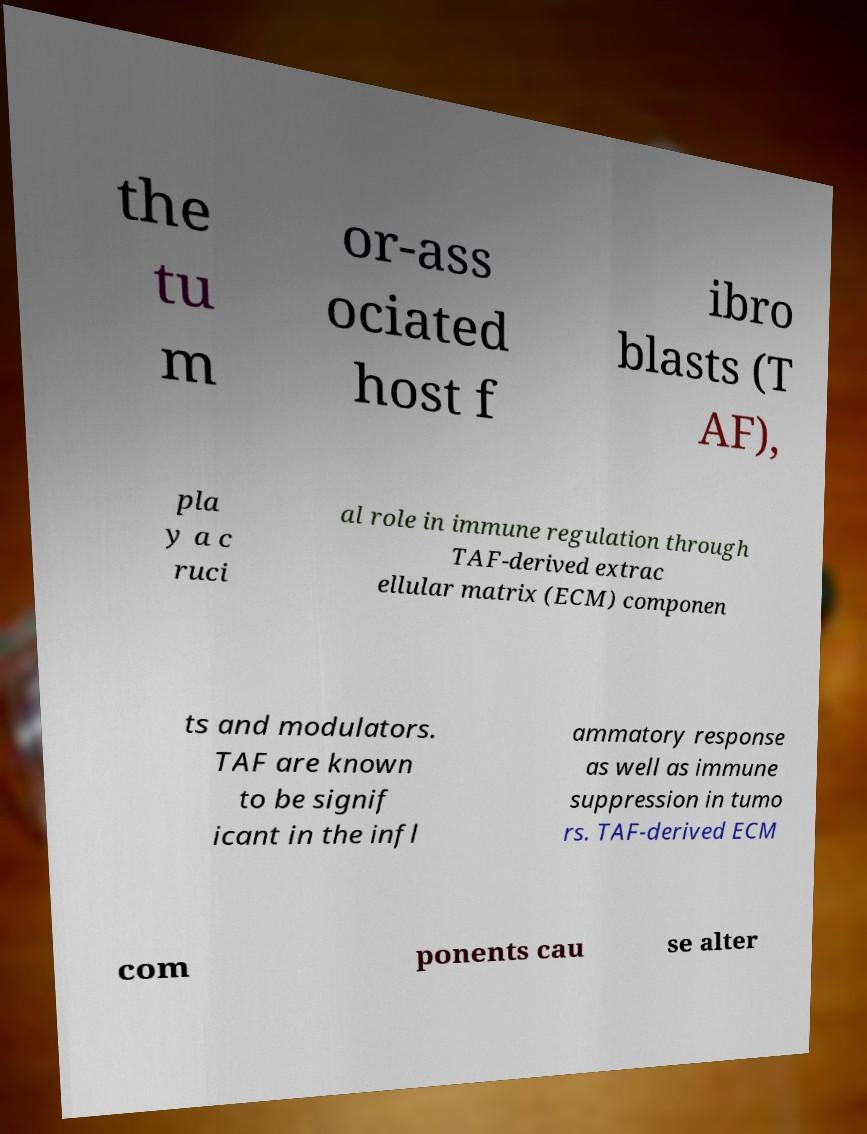Please identify and transcribe the text found in this image. the tu m or-ass ociated host f ibro blasts (T AF), pla y a c ruci al role in immune regulation through TAF-derived extrac ellular matrix (ECM) componen ts and modulators. TAF are known to be signif icant in the infl ammatory response as well as immune suppression in tumo rs. TAF-derived ECM com ponents cau se alter 